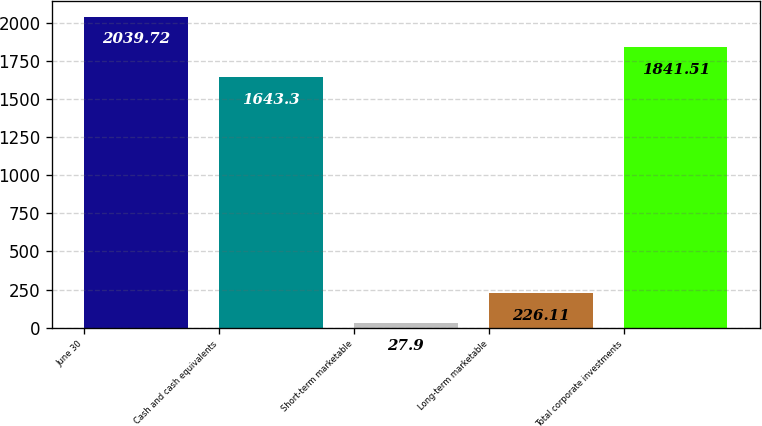<chart> <loc_0><loc_0><loc_500><loc_500><bar_chart><fcel>June 30<fcel>Cash and cash equivalents<fcel>Short-term marketable<fcel>Long-term marketable<fcel>Total corporate investments<nl><fcel>2039.72<fcel>1643.3<fcel>27.9<fcel>226.11<fcel>1841.51<nl></chart> 